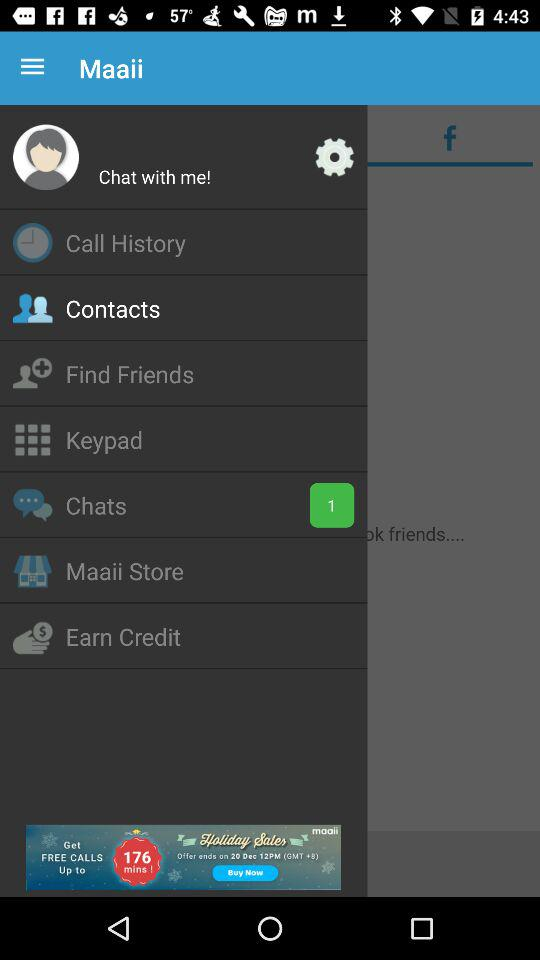Which option has been selected? The option that has been selected is "Contacts". 